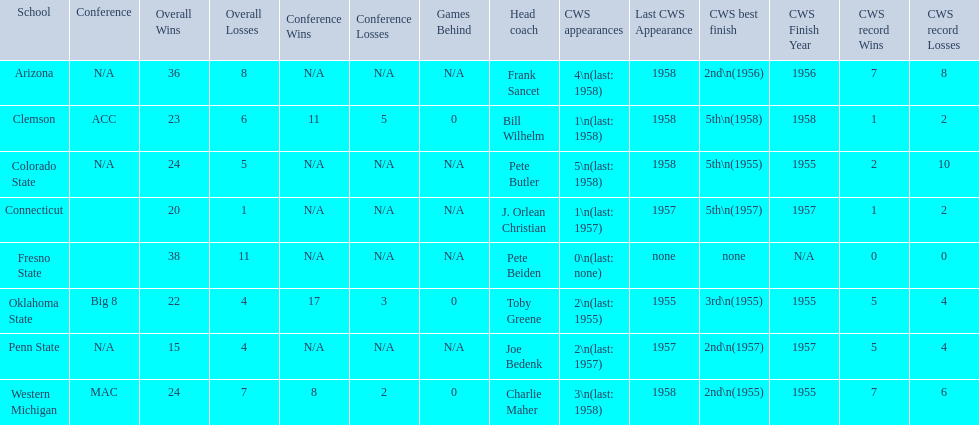What were scores for each school in the 1959 ncaa tournament? 36–8 (N/A), 23 –6 (11–5, 0 GB), 24–5 (N/A), 20–1 (N/A), 38–11 (N/A), 22–4 (17–3, 0 GB), 15–4 (N/A), 24–7 (8–2, 0 GB). What score did not have at least 16 wins? 15–4 (N/A). What team earned this score? Penn State. 